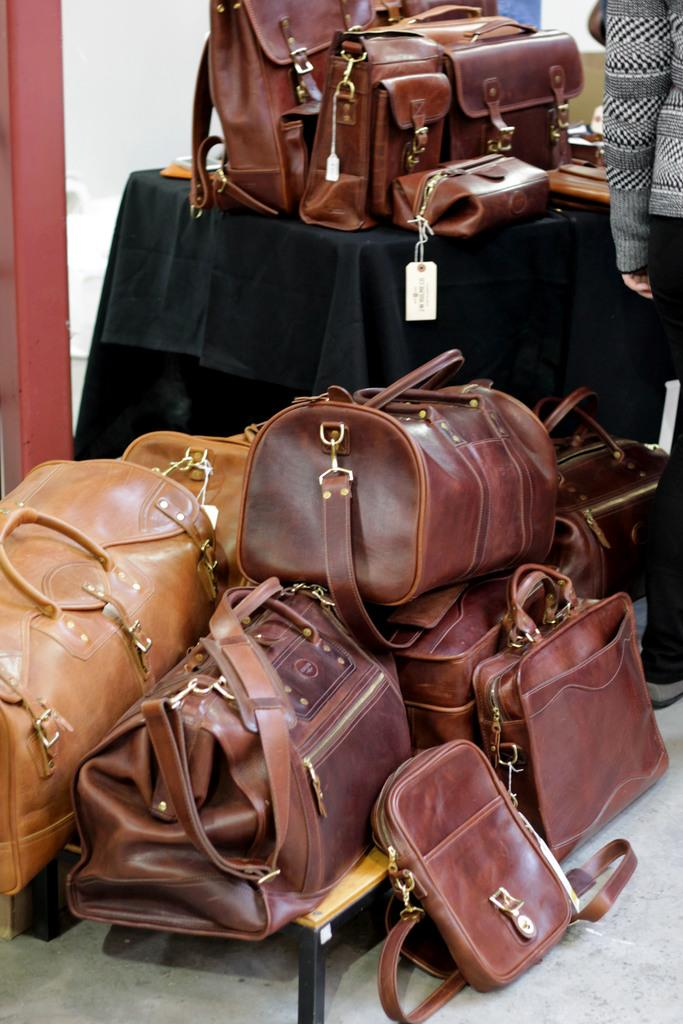What objects can be seen in the image? There are bags and a table in the image. What is the table's condition or state? The table has bags on it. Is there anyone present in the image? Yes, there is a person in the image. What type of knowledge can be gained from the mitten in the image? There is no mitten present in the image, so no knowledge can be gained from it. What appliance is being used by the person in the image? The provided facts do not mention any appliances, so it cannot be determined which appliance the person might be using. 